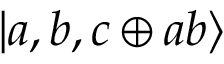Convert formula to latex. <formula><loc_0><loc_0><loc_500><loc_500>| a , b , c \oplus a b \rangle</formula> 